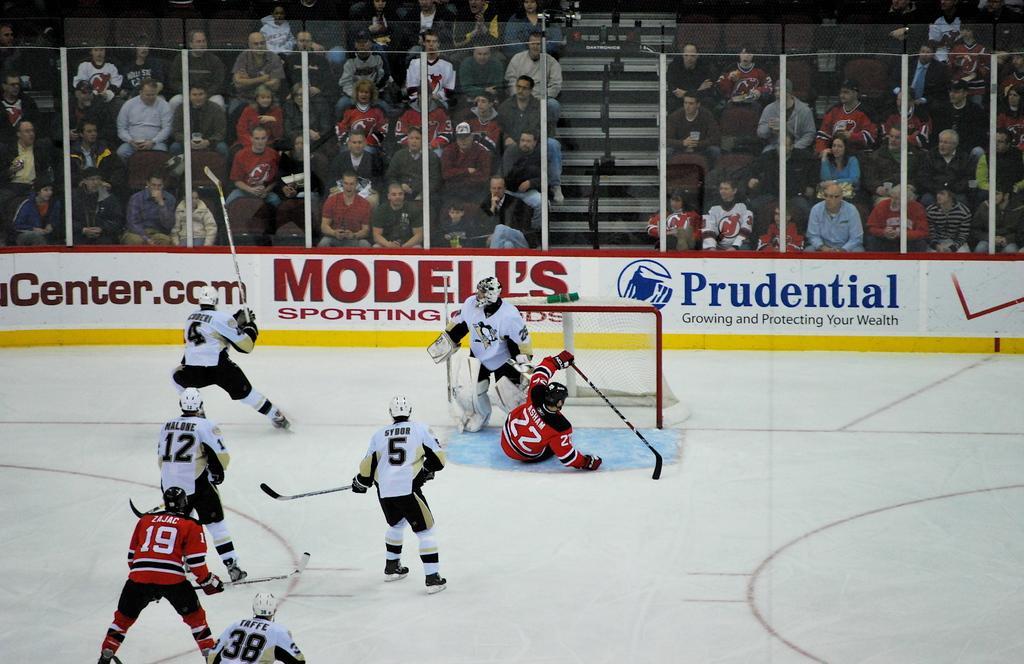How would you summarize this image in a sentence or two? This picture consists of a skating surface in the foreground, in the surface I can see there are few persons holding sticks visible , there is a fence, back side of fence there is a crowd and people sitting on chairs , in the middle there is a staircase, in front of fence there is a banner, on the banner there is a text visible. 